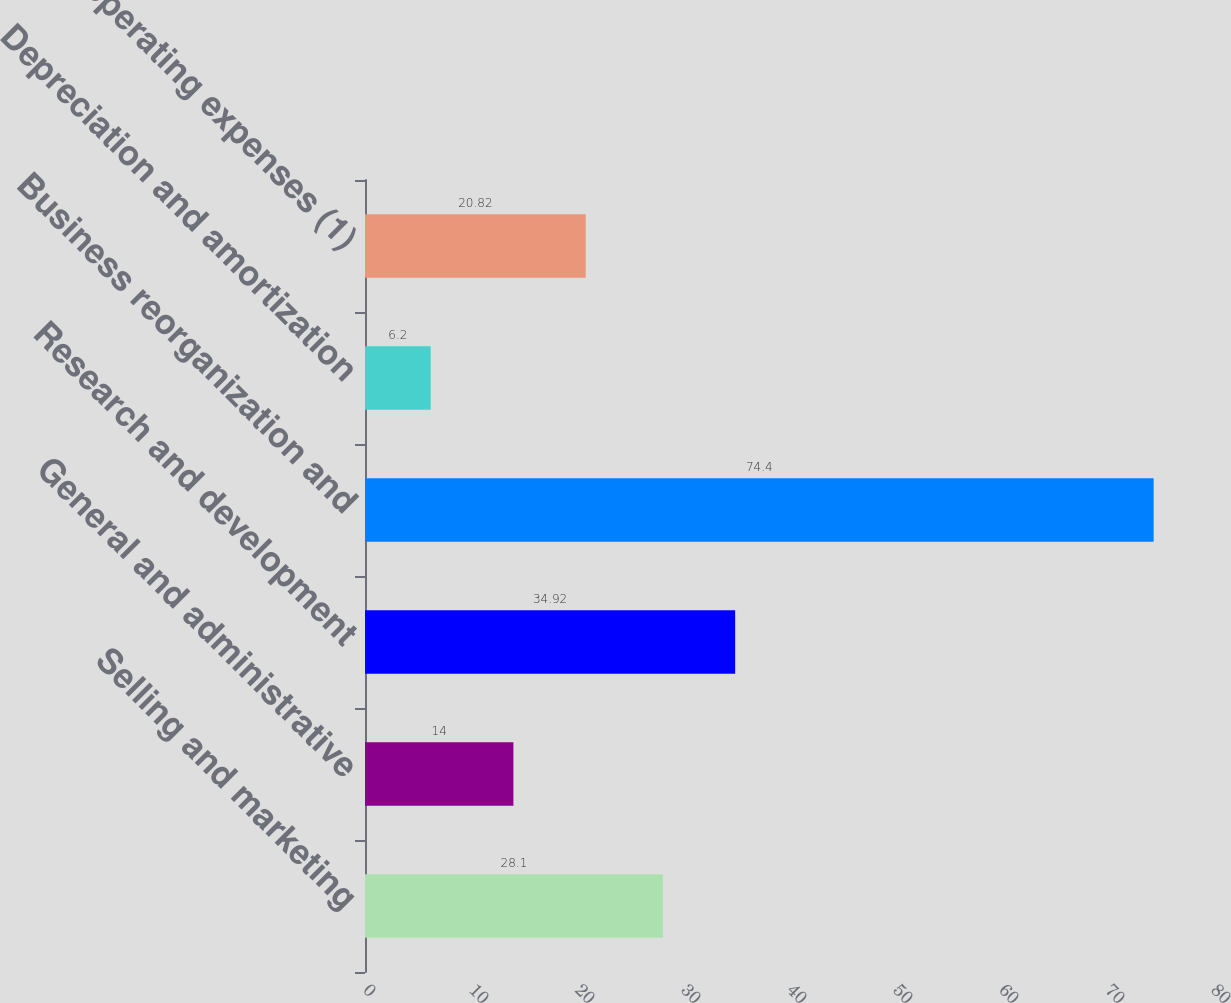<chart> <loc_0><loc_0><loc_500><loc_500><bar_chart><fcel>Selling and marketing<fcel>General and administrative<fcel>Research and development<fcel>Business reorganization and<fcel>Depreciation and amortization<fcel>Total operating expenses (1)<nl><fcel>28.1<fcel>14<fcel>34.92<fcel>74.4<fcel>6.2<fcel>20.82<nl></chart> 